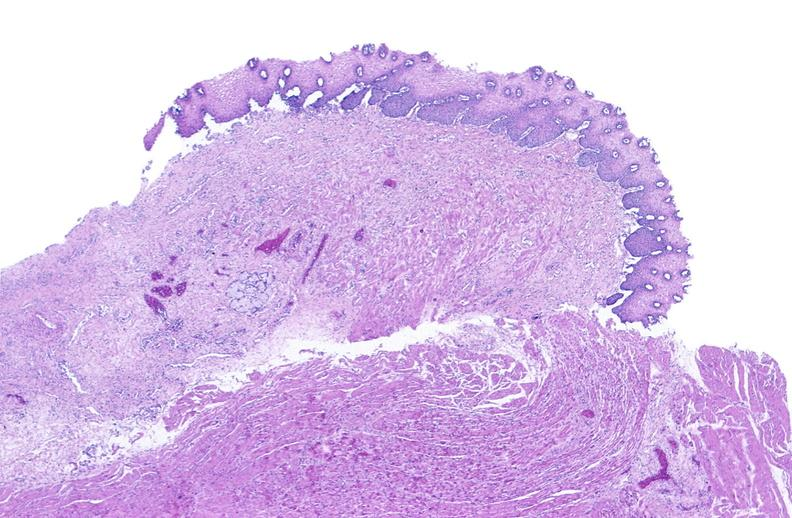s gastrointestinal present?
Answer the question using a single word or phrase. Yes 